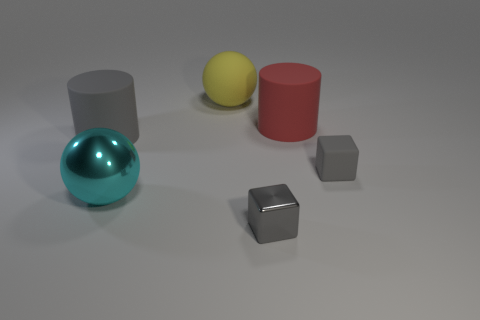What material is the other tiny cube that is the same color as the small matte block?
Your response must be concise. Metal. Is the color of the cylinder that is right of the big gray rubber thing the same as the large metal object that is in front of the small gray rubber object?
Your answer should be very brief. No. Are there any red matte things of the same shape as the yellow object?
Give a very brief answer. No. How many other things are the same color as the small metallic object?
Your answer should be very brief. 2. What is the color of the cylinder behind the large rubber object that is on the left side of the metal thing that is left of the shiny block?
Your answer should be compact. Red. Are there an equal number of gray shiny cubes that are behind the gray metal thing and small red spheres?
Offer a terse response. Yes. Is the size of the gray object left of the cyan object the same as the red rubber cylinder?
Your answer should be compact. Yes. What number of gray rubber cubes are there?
Provide a short and direct response. 1. What number of objects are both behind the large cyan metallic thing and right of the cyan metallic object?
Offer a very short reply. 3. Is there another small cyan thing made of the same material as the cyan object?
Make the answer very short. No. 